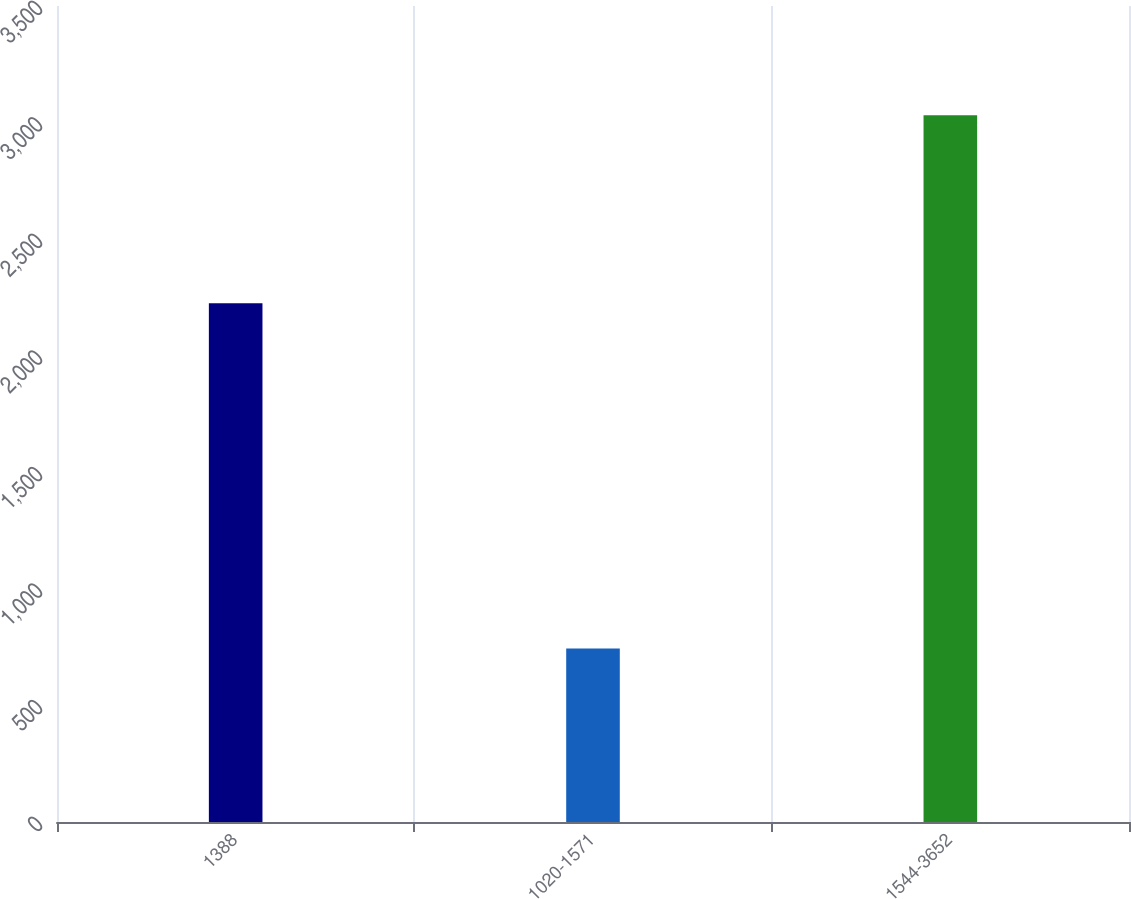Convert chart. <chart><loc_0><loc_0><loc_500><loc_500><bar_chart><fcel>1388<fcel>1020-1571<fcel>1544-3652<nl><fcel>2225<fcel>744<fcel>3031<nl></chart> 